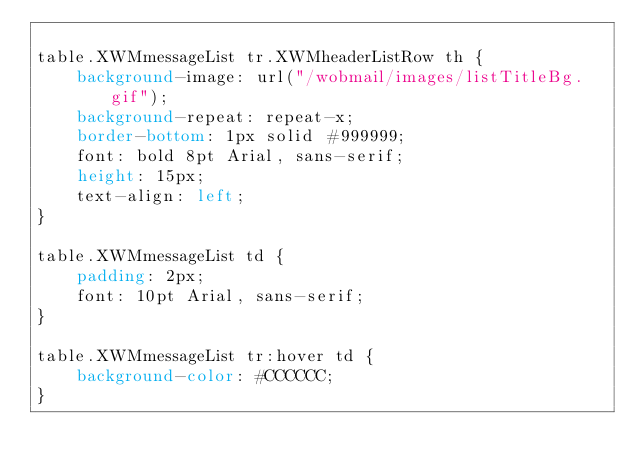Convert code to text. <code><loc_0><loc_0><loc_500><loc_500><_CSS_>
table.XWMmessageList tr.XWMheaderListRow th {
	background-image: url("/wobmail/images/listTitleBg.gif");
	background-repeat: repeat-x;
	border-bottom: 1px solid #999999;
	font: bold 8pt Arial, sans-serif;
	height: 15px;
	text-align: left;
}

table.XWMmessageList td {
	padding: 2px;
	font: 10pt Arial, sans-serif;
}

table.XWMmessageList tr:hover td {
	background-color: #CCCCCC;
}
</code> 